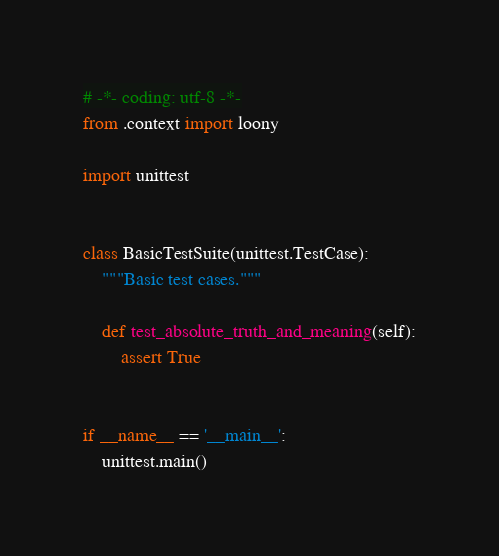<code> <loc_0><loc_0><loc_500><loc_500><_Python_># -*- coding: utf-8 -*-
from .context import loony

import unittest


class BasicTestSuite(unittest.TestCase):
    """Basic test cases."""

    def test_absolute_truth_and_meaning(self):
        assert True


if __name__ == '__main__':
    unittest.main()
</code> 